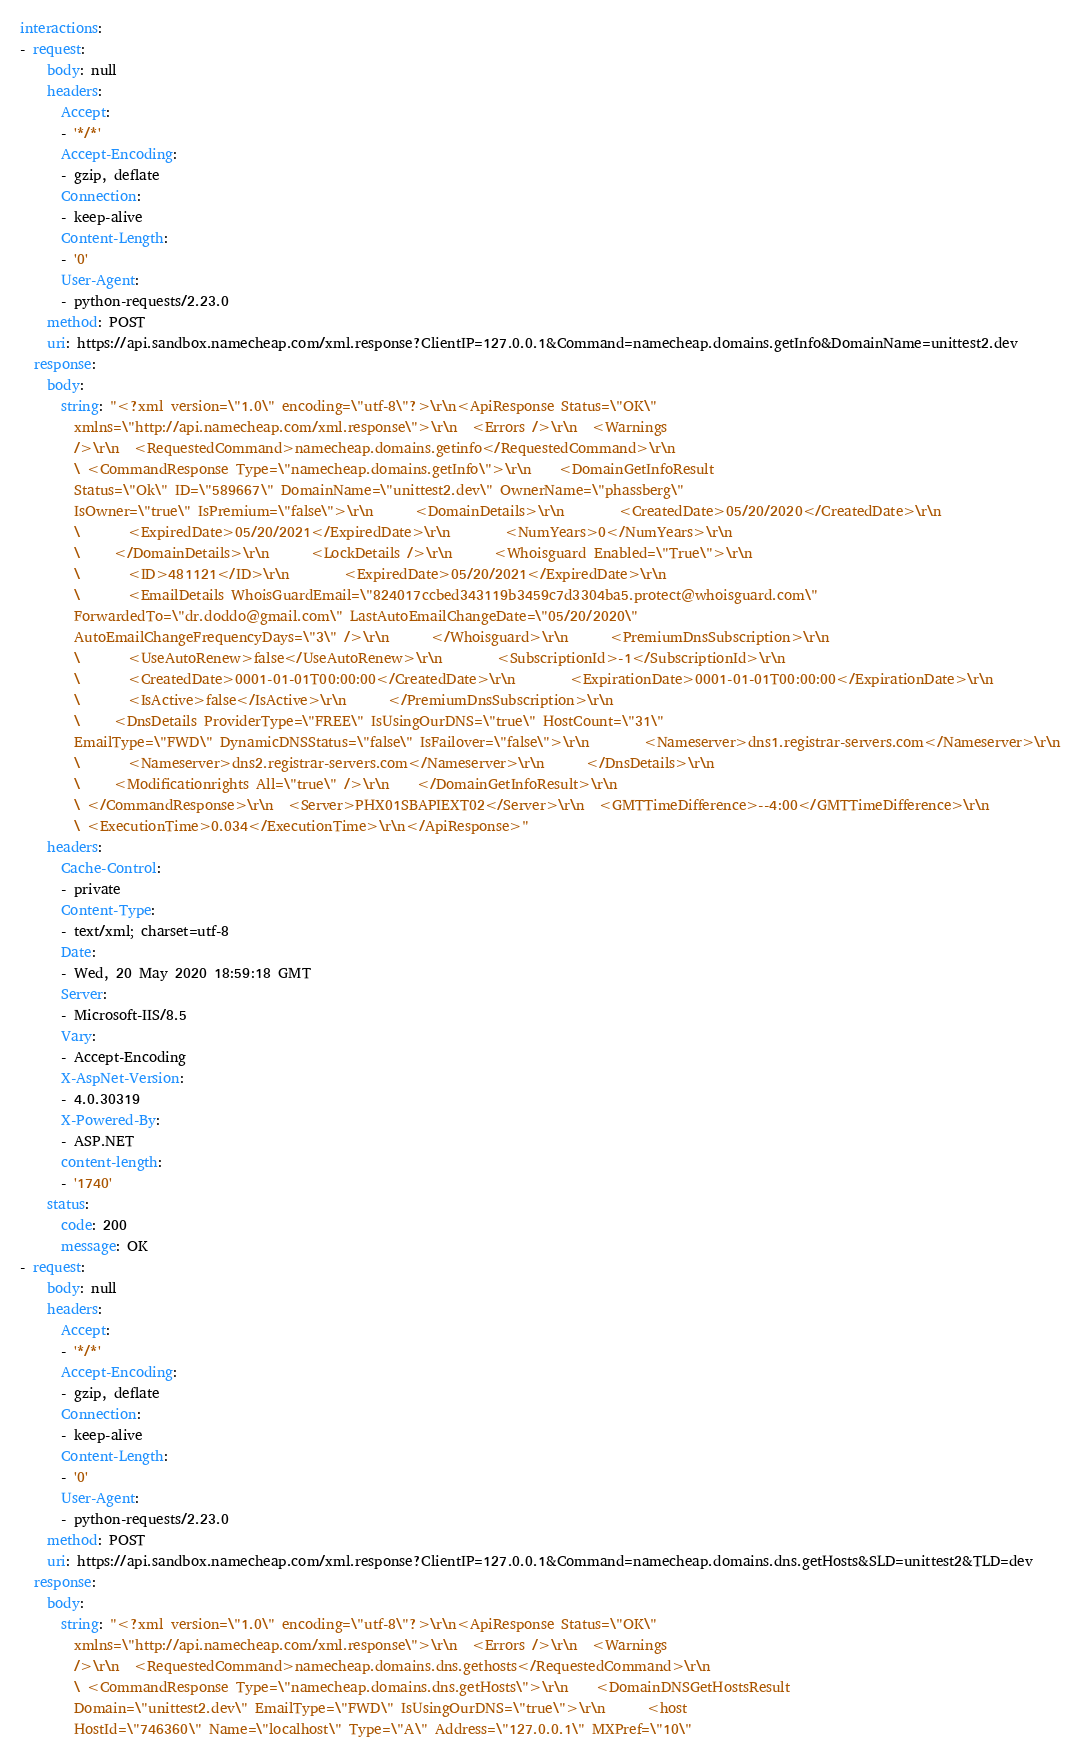<code> <loc_0><loc_0><loc_500><loc_500><_YAML_>interactions:
- request:
    body: null
    headers:
      Accept:
      - '*/*'
      Accept-Encoding:
      - gzip, deflate
      Connection:
      - keep-alive
      Content-Length:
      - '0'
      User-Agent:
      - python-requests/2.23.0
    method: POST
    uri: https://api.sandbox.namecheap.com/xml.response?ClientIP=127.0.0.1&Command=namecheap.domains.getInfo&DomainName=unittest2.dev
  response:
    body:
      string: "<?xml version=\"1.0\" encoding=\"utf-8\"?>\r\n<ApiResponse Status=\"OK\"
        xmlns=\"http://api.namecheap.com/xml.response\">\r\n  <Errors />\r\n  <Warnings
        />\r\n  <RequestedCommand>namecheap.domains.getinfo</RequestedCommand>\r\n
        \ <CommandResponse Type=\"namecheap.domains.getInfo\">\r\n    <DomainGetInfoResult
        Status=\"Ok\" ID=\"589667\" DomainName=\"unittest2.dev\" OwnerName=\"phassberg\"
        IsOwner=\"true\" IsPremium=\"false\">\r\n      <DomainDetails>\r\n        <CreatedDate>05/20/2020</CreatedDate>\r\n
        \       <ExpiredDate>05/20/2021</ExpiredDate>\r\n        <NumYears>0</NumYears>\r\n
        \     </DomainDetails>\r\n      <LockDetails />\r\n      <Whoisguard Enabled=\"True\">\r\n
        \       <ID>481121</ID>\r\n        <ExpiredDate>05/20/2021</ExpiredDate>\r\n
        \       <EmailDetails WhoisGuardEmail=\"824017ccbed343119b3459c7d3304ba5.protect@whoisguard.com\"
        ForwardedTo=\"dr.doddo@gmail.com\" LastAutoEmailChangeDate=\"05/20/2020\"
        AutoEmailChangeFrequencyDays=\"3\" />\r\n      </Whoisguard>\r\n      <PremiumDnsSubscription>\r\n
        \       <UseAutoRenew>false</UseAutoRenew>\r\n        <SubscriptionId>-1</SubscriptionId>\r\n
        \       <CreatedDate>0001-01-01T00:00:00</CreatedDate>\r\n        <ExpirationDate>0001-01-01T00:00:00</ExpirationDate>\r\n
        \       <IsActive>false</IsActive>\r\n      </PremiumDnsSubscription>\r\n
        \     <DnsDetails ProviderType=\"FREE\" IsUsingOurDNS=\"true\" HostCount=\"31\"
        EmailType=\"FWD\" DynamicDNSStatus=\"false\" IsFailover=\"false\">\r\n        <Nameserver>dns1.registrar-servers.com</Nameserver>\r\n
        \       <Nameserver>dns2.registrar-servers.com</Nameserver>\r\n      </DnsDetails>\r\n
        \     <Modificationrights All=\"true\" />\r\n    </DomainGetInfoResult>\r\n
        \ </CommandResponse>\r\n  <Server>PHX01SBAPIEXT02</Server>\r\n  <GMTTimeDifference>--4:00</GMTTimeDifference>\r\n
        \ <ExecutionTime>0.034</ExecutionTime>\r\n</ApiResponse>"
    headers:
      Cache-Control:
      - private
      Content-Type:
      - text/xml; charset=utf-8
      Date:
      - Wed, 20 May 2020 18:59:18 GMT
      Server:
      - Microsoft-IIS/8.5
      Vary:
      - Accept-Encoding
      X-AspNet-Version:
      - 4.0.30319
      X-Powered-By:
      - ASP.NET
      content-length:
      - '1740'
    status:
      code: 200
      message: OK
- request:
    body: null
    headers:
      Accept:
      - '*/*'
      Accept-Encoding:
      - gzip, deflate
      Connection:
      - keep-alive
      Content-Length:
      - '0'
      User-Agent:
      - python-requests/2.23.0
    method: POST
    uri: https://api.sandbox.namecheap.com/xml.response?ClientIP=127.0.0.1&Command=namecheap.domains.dns.getHosts&SLD=unittest2&TLD=dev
  response:
    body:
      string: "<?xml version=\"1.0\" encoding=\"utf-8\"?>\r\n<ApiResponse Status=\"OK\"
        xmlns=\"http://api.namecheap.com/xml.response\">\r\n  <Errors />\r\n  <Warnings
        />\r\n  <RequestedCommand>namecheap.domains.dns.gethosts</RequestedCommand>\r\n
        \ <CommandResponse Type=\"namecheap.domains.dns.getHosts\">\r\n    <DomainDNSGetHostsResult
        Domain=\"unittest2.dev\" EmailType=\"FWD\" IsUsingOurDNS=\"true\">\r\n      <host
        HostId=\"746360\" Name=\"localhost\" Type=\"A\" Address=\"127.0.0.1\" MXPref=\"10\"</code> 